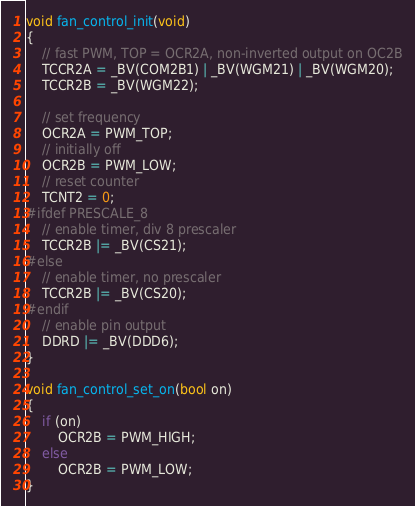<code> <loc_0><loc_0><loc_500><loc_500><_C_>void fan_control_init(void)
{
    // fast PWM, TOP = OCR2A, non-inverted output on OC2B
    TCCR2A = _BV(COM2B1) | _BV(WGM21) | _BV(WGM20);
    TCCR2B = _BV(WGM22);

    // set frequency
    OCR2A = PWM_TOP;
    // initially off
    OCR2B = PWM_LOW;
    // reset counter
    TCNT2 = 0;
#ifdef PRESCALE_8
    // enable timer, div 8 prescaler
    TCCR2B |= _BV(CS21);
#else
    // enable timer, no prescaler
    TCCR2B |= _BV(CS20);
#endif
    // enable pin output
    DDRD |= _BV(DDD6);
}

void fan_control_set_on(bool on)
{
    if (on)
        OCR2B = PWM_HIGH;
    else
        OCR2B = PWM_LOW;
}
</code> 